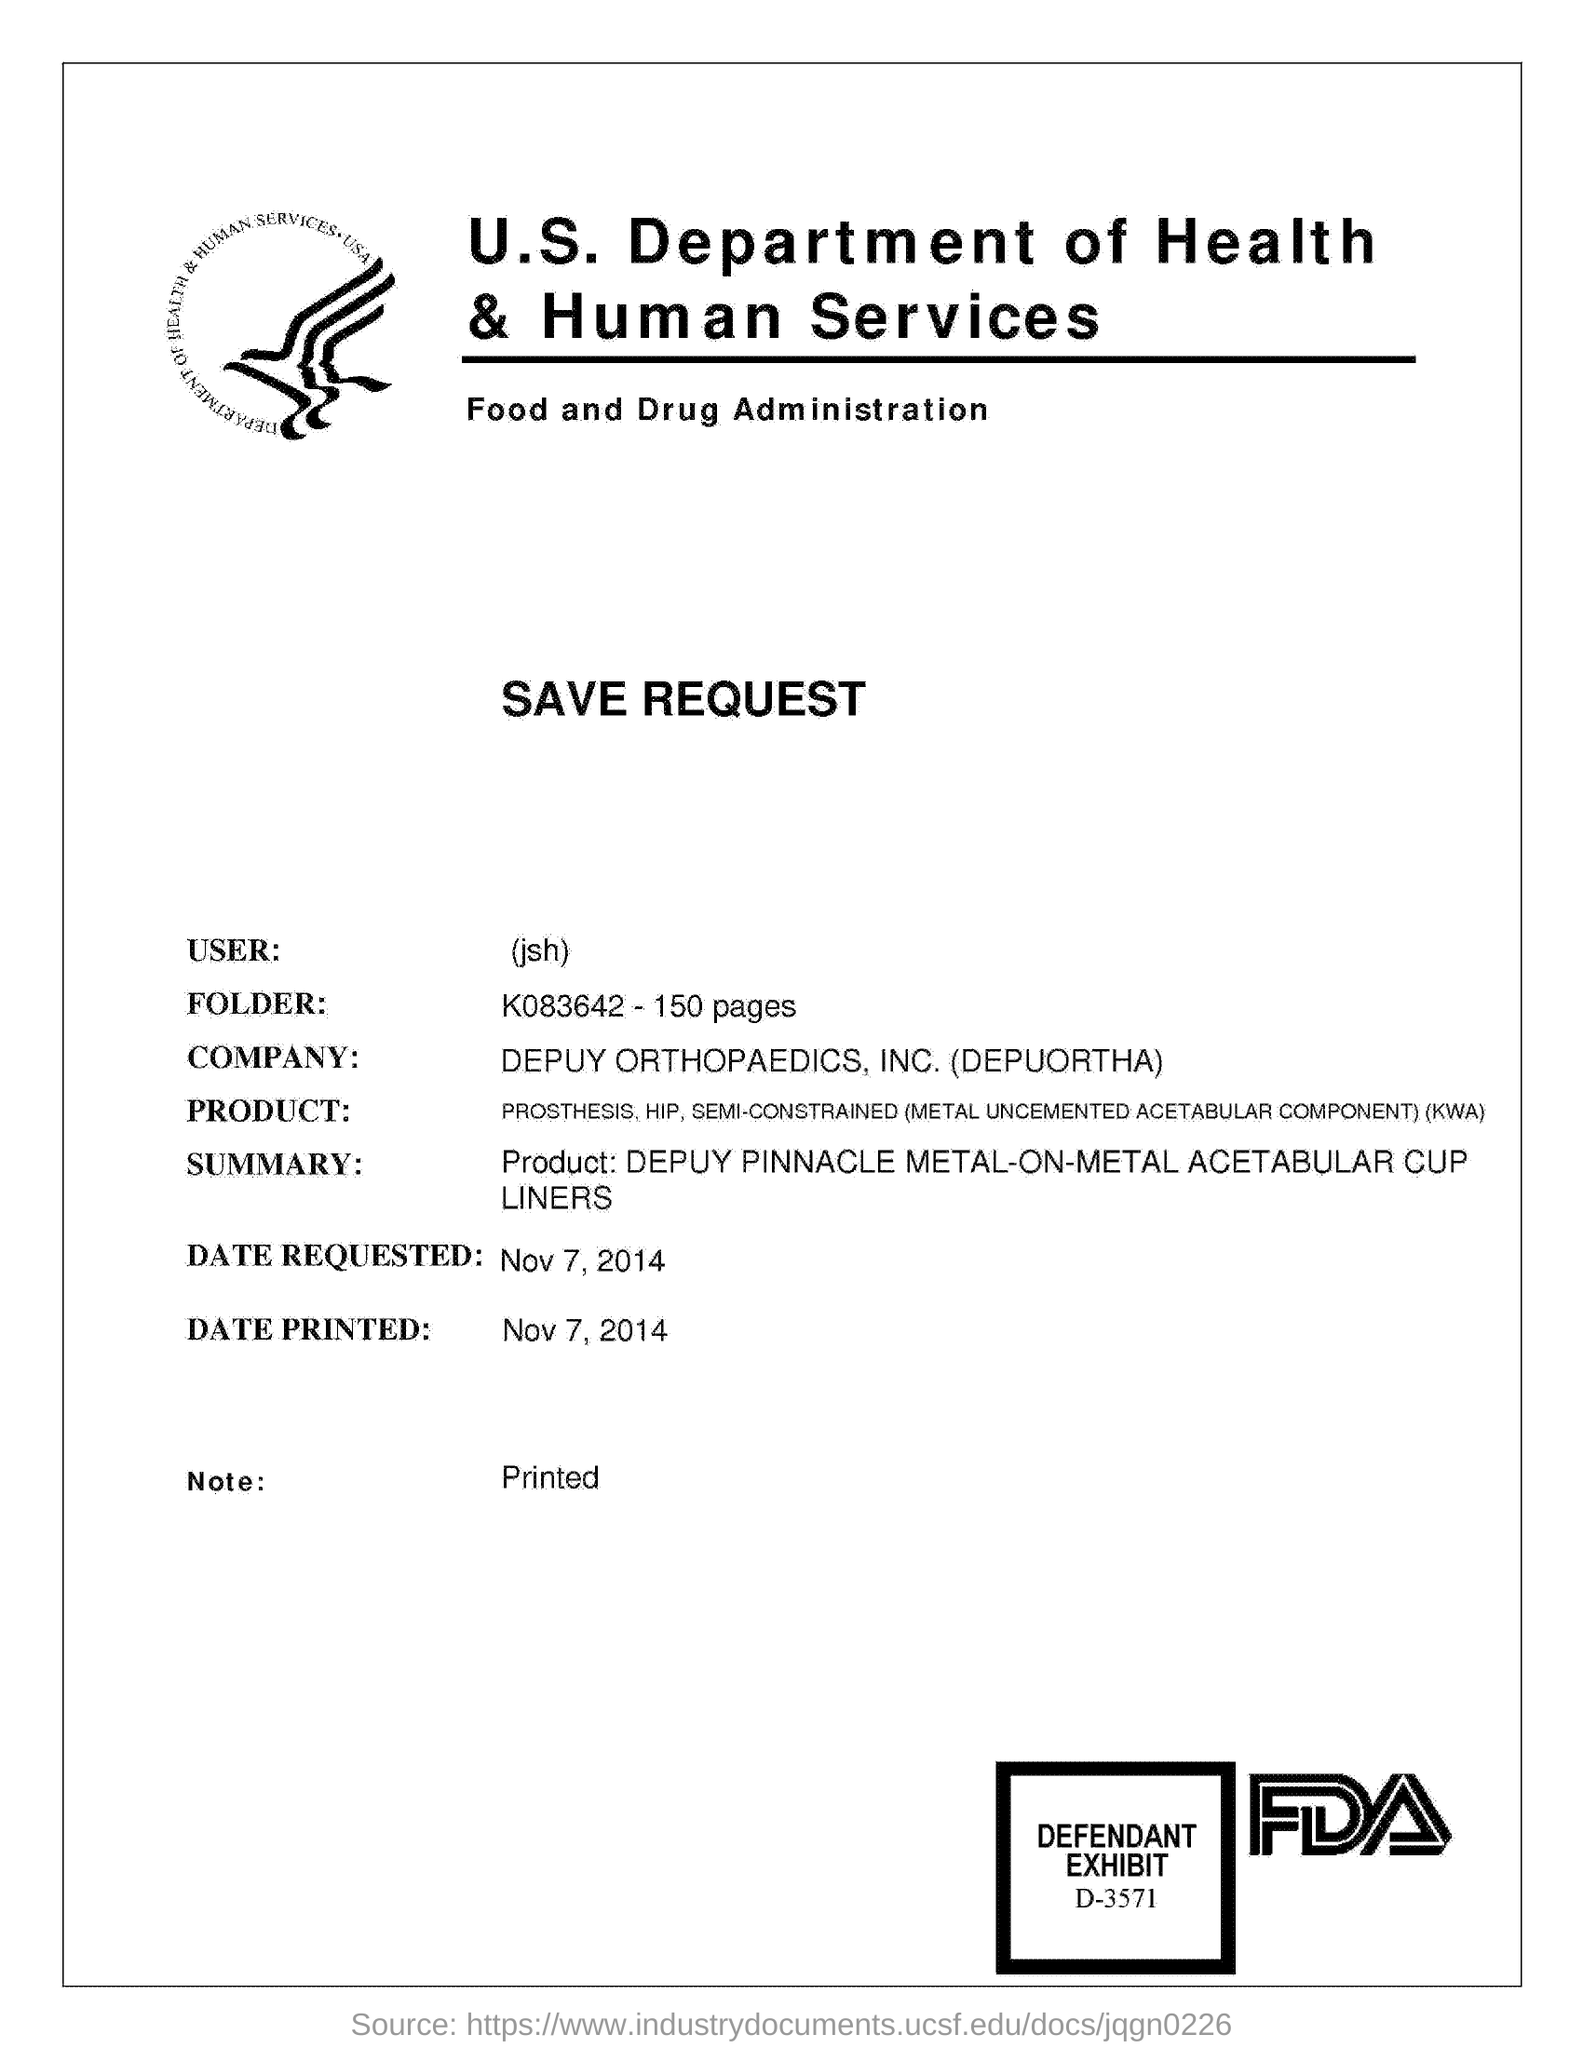Which department is mentioned?
Provide a short and direct response. U.S. Department of Health & Human Services. Which folder is mentioned?
Give a very brief answer. K083642 - 150 pages. Which company's name is mentioned?
Provide a succinct answer. DEPUY ORTHOPAEDICS, INC. (DEPUORTHA). When is the date requested?
Offer a terse response. Nov 7, 2014. When is the date printed?
Give a very brief answer. Nov 7, 2014. 